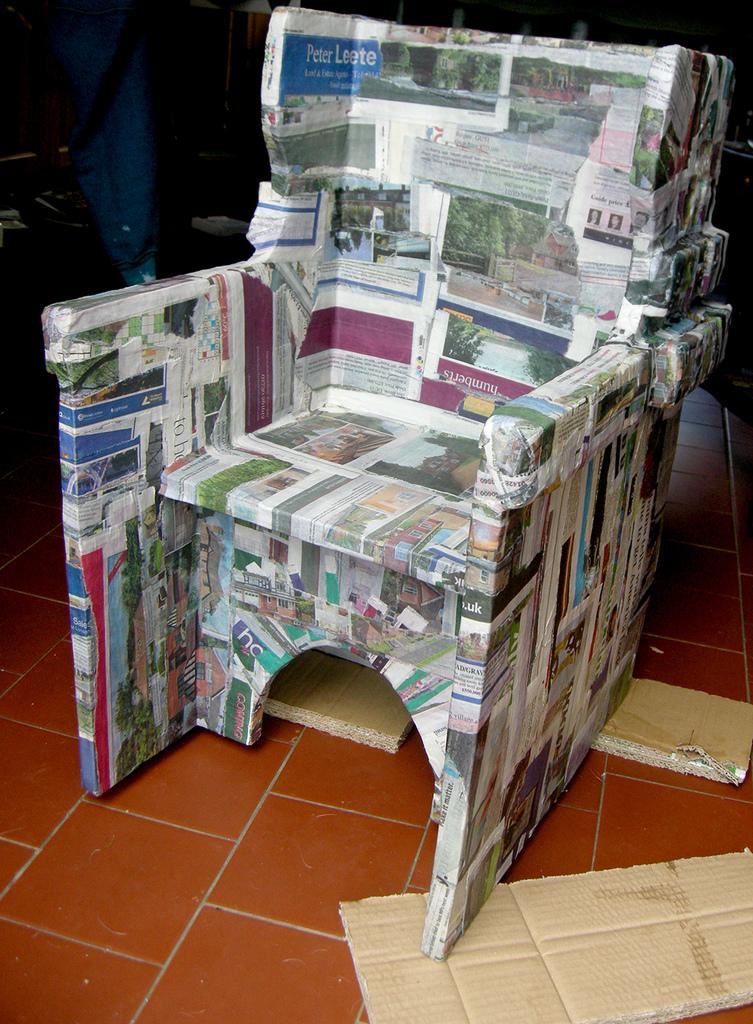What material is the floor made of in the image? The floor in the image is made of marble. What type of furniture can be seen in the image? There is a chair in the image. What is covering the chair in the image? A newspaper is pasted onto the chair. What is supporting the chair in the image? There are cardboard pieces at the bottom of the chair. How many cats are sitting on the gate in the image? There are no cats or gates present in the image. 